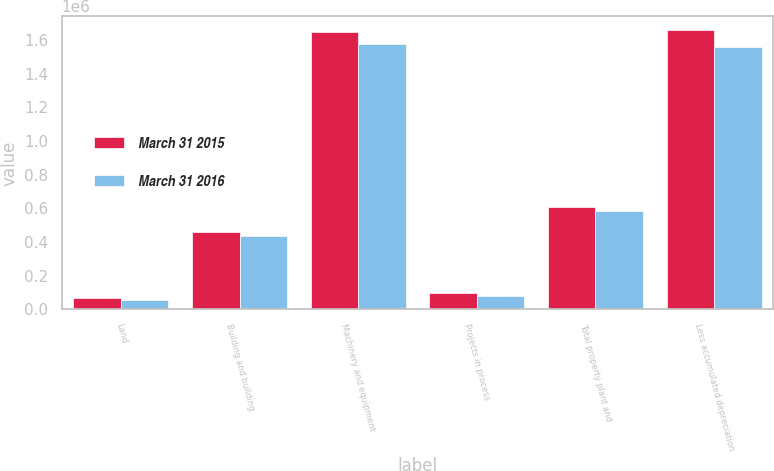Convert chart. <chart><loc_0><loc_0><loc_500><loc_500><stacked_bar_chart><ecel><fcel>Land<fcel>Building and building<fcel>Machinery and equipment<fcel>Projects in process<fcel>Total property plant and<fcel>Less accumulated depreciation<nl><fcel>March 31 2015<fcel>63907<fcel>458379<fcel>1.64562e+06<fcel>99370<fcel>609396<fcel>1.65788e+06<nl><fcel>March 31 2016<fcel>55624<fcel>434403<fcel>1.57607e+06<fcel>76315<fcel>581572<fcel>1.56084e+06<nl></chart> 